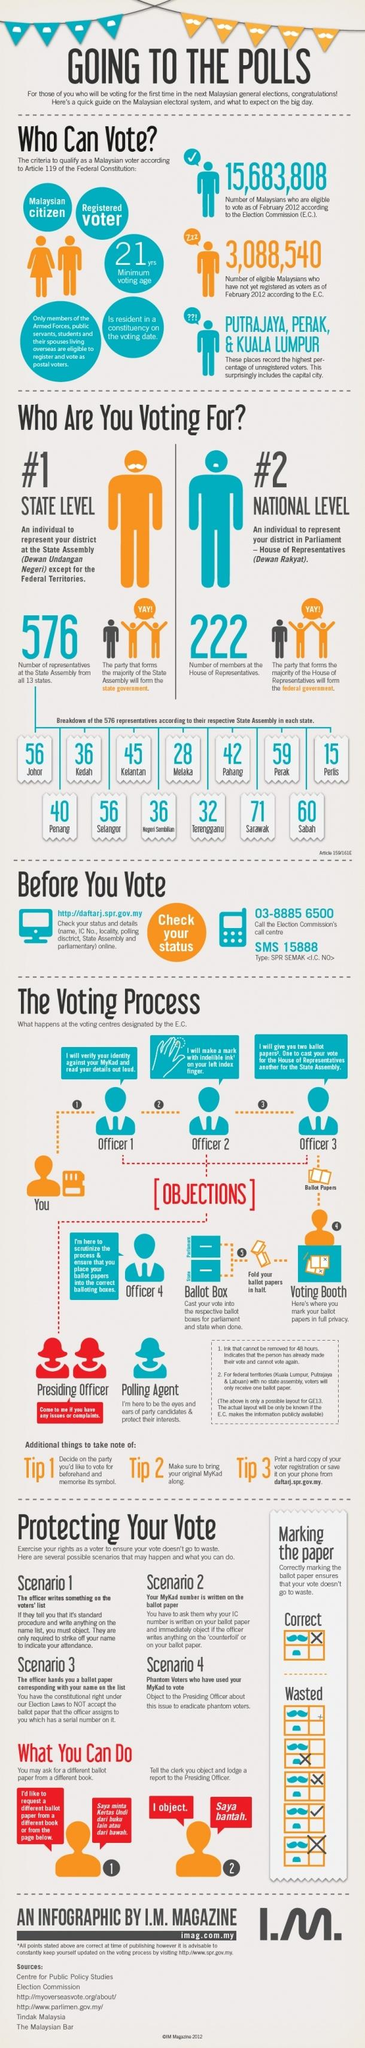Give some essential details in this illustration. There are 36 representatives from Kedah in the State Assembly. Sarawak has the highest number of representatives in the State Assembly. Perlis has the lowest number of representatives in the State Assembly. There are 28 representatives from the state of Melaka in the State Assembly. There are currently 222 members in the House of Representatives. 